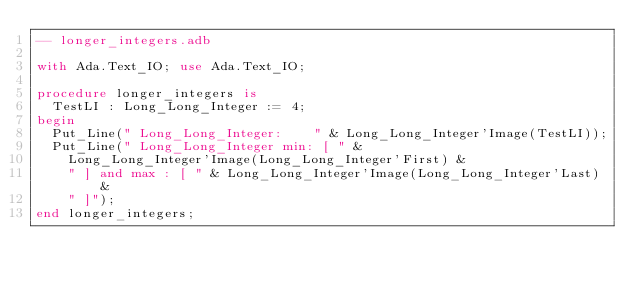Convert code to text. <code><loc_0><loc_0><loc_500><loc_500><_Ada_>-- longer_integers.adb

with Ada.Text_IO; use Ada.Text_IO;

procedure longer_integers is
	TestLI : Long_Long_Integer := 4;
begin
	Put_Line(" Long_Long_Integer:    " & Long_Long_Integer'Image(TestLI));
	Put_Line(" Long_Long_Integer min: [ " &
		Long_Long_Integer'Image(Long_Long_Integer'First) &
		" ] and max : [ " & Long_Long_Integer'Image(Long_Long_Integer'Last) &
		" ]");
end longer_integers;
</code> 